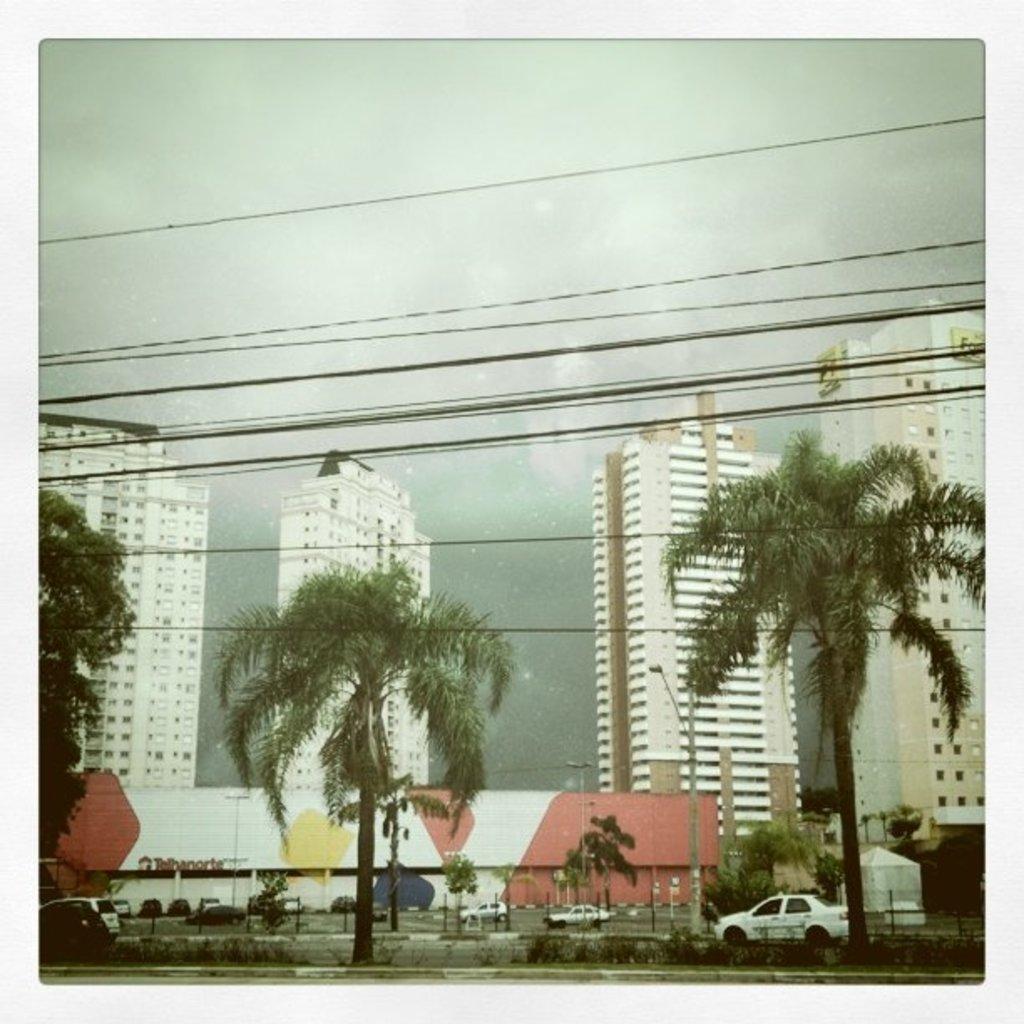Could you give a brief overview of what you see in this image? In this image there are cars on the road and there are trees, poles, in the background there are buildings, wires and the sky. 